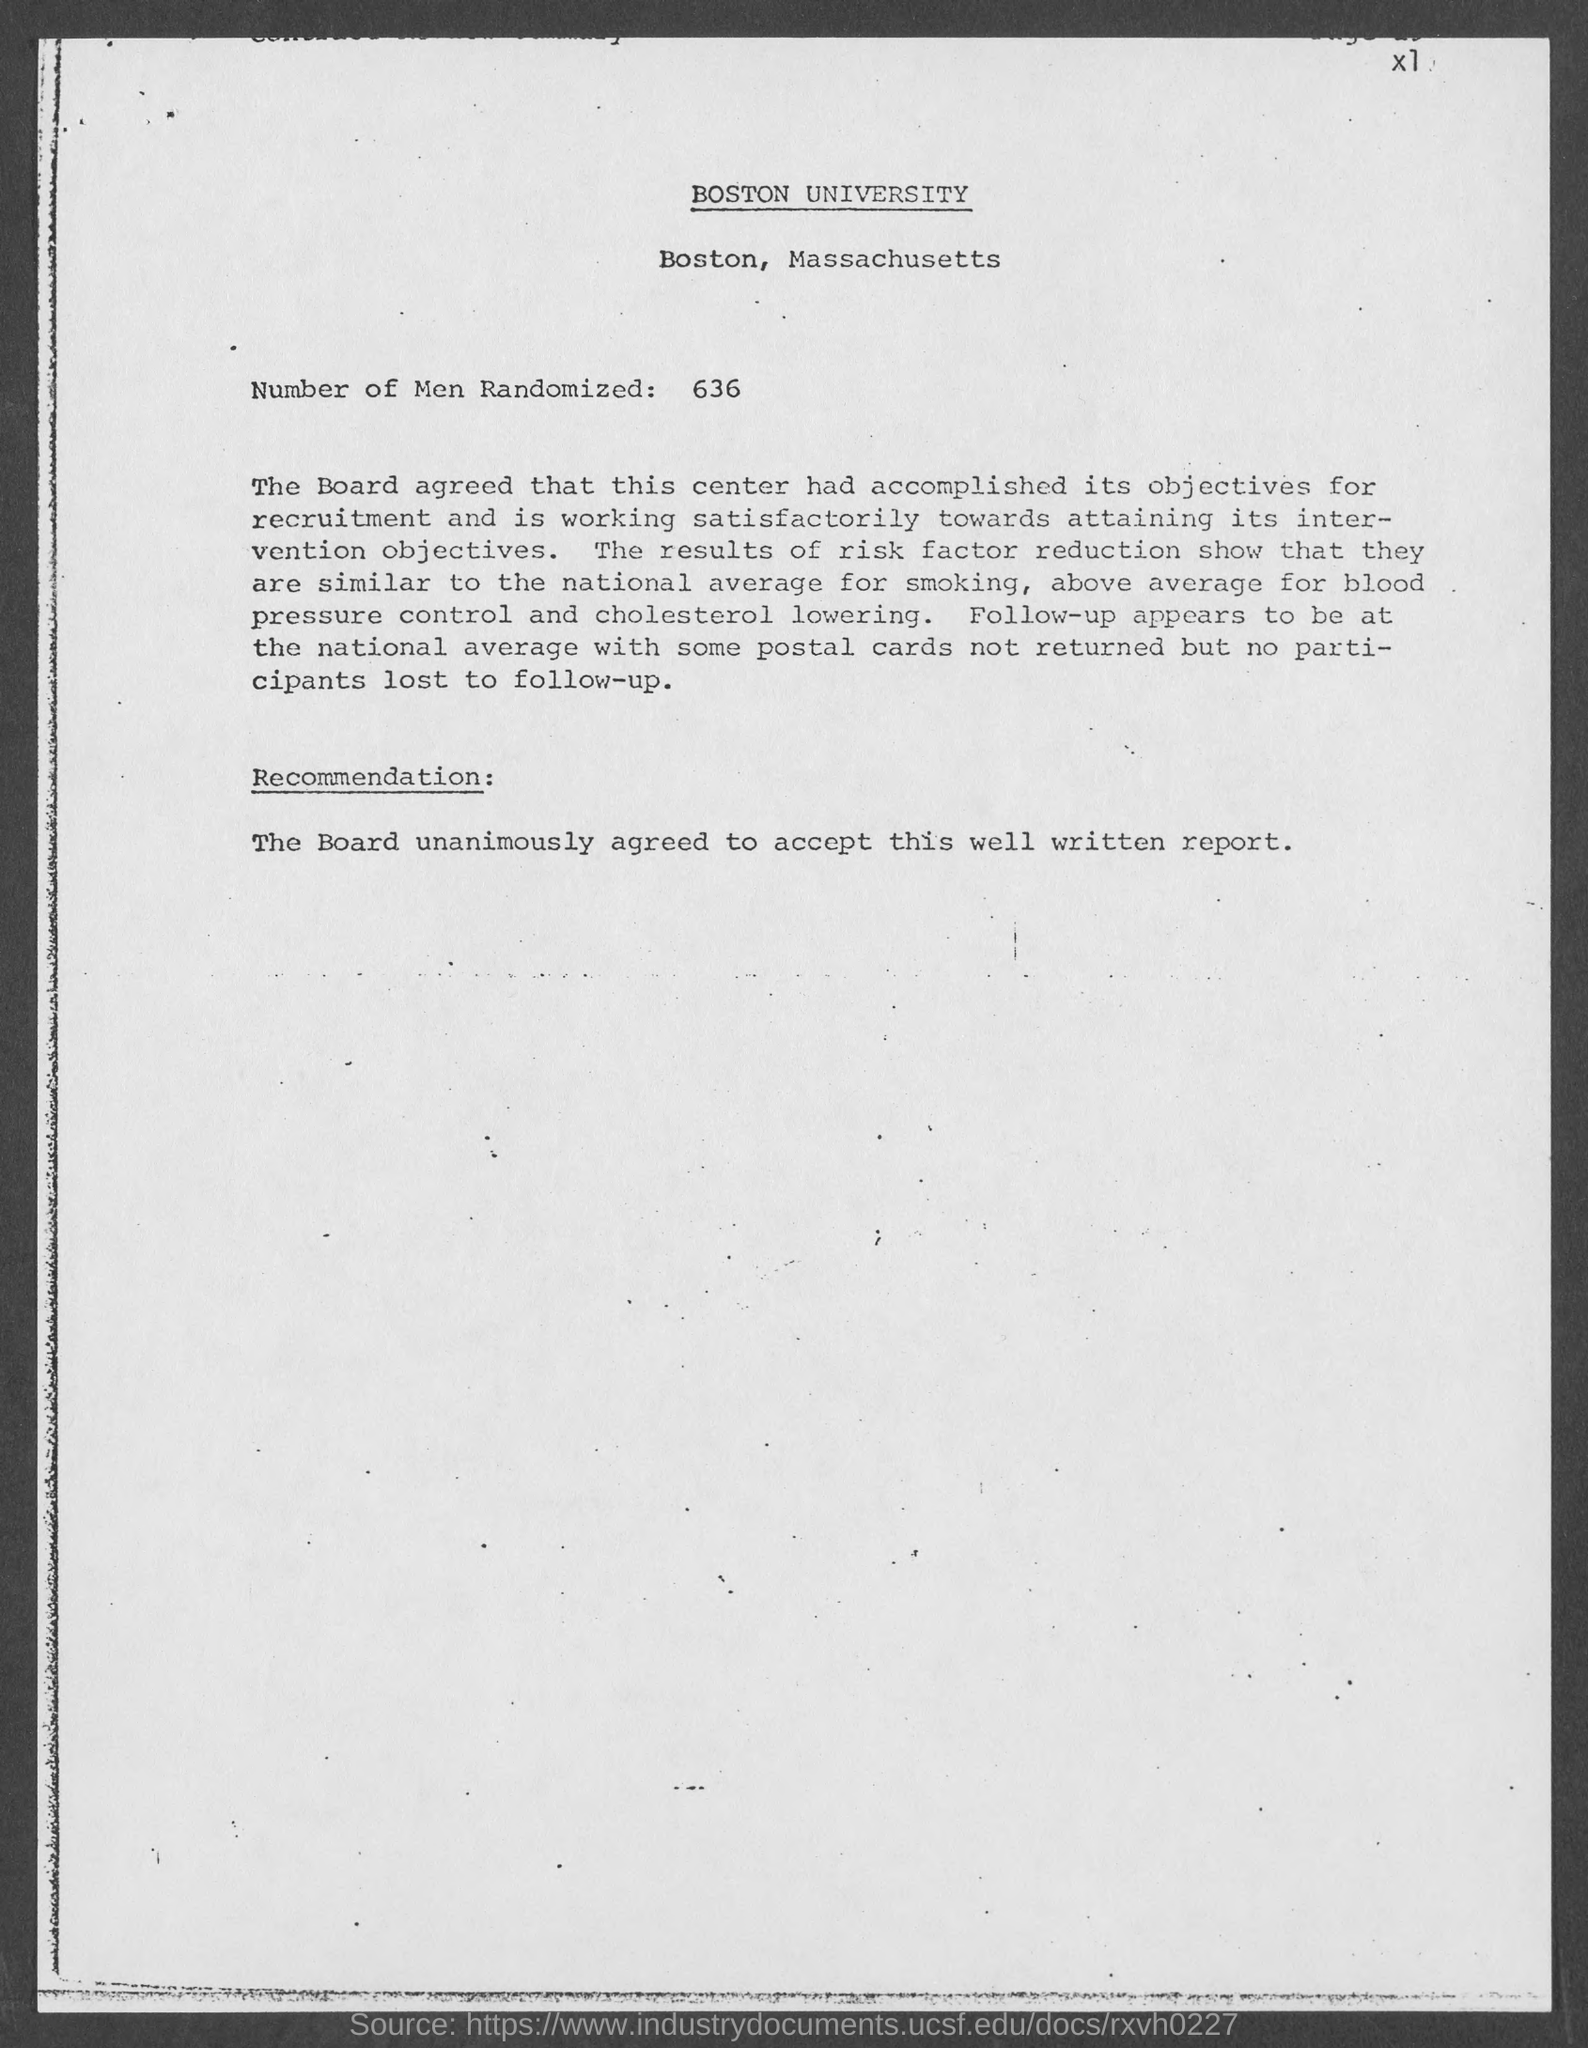Where "Boston University" is located?
Offer a very short reply. Boston, Massachusetts. How many number of men randomized?
Offer a terse response. 636. 